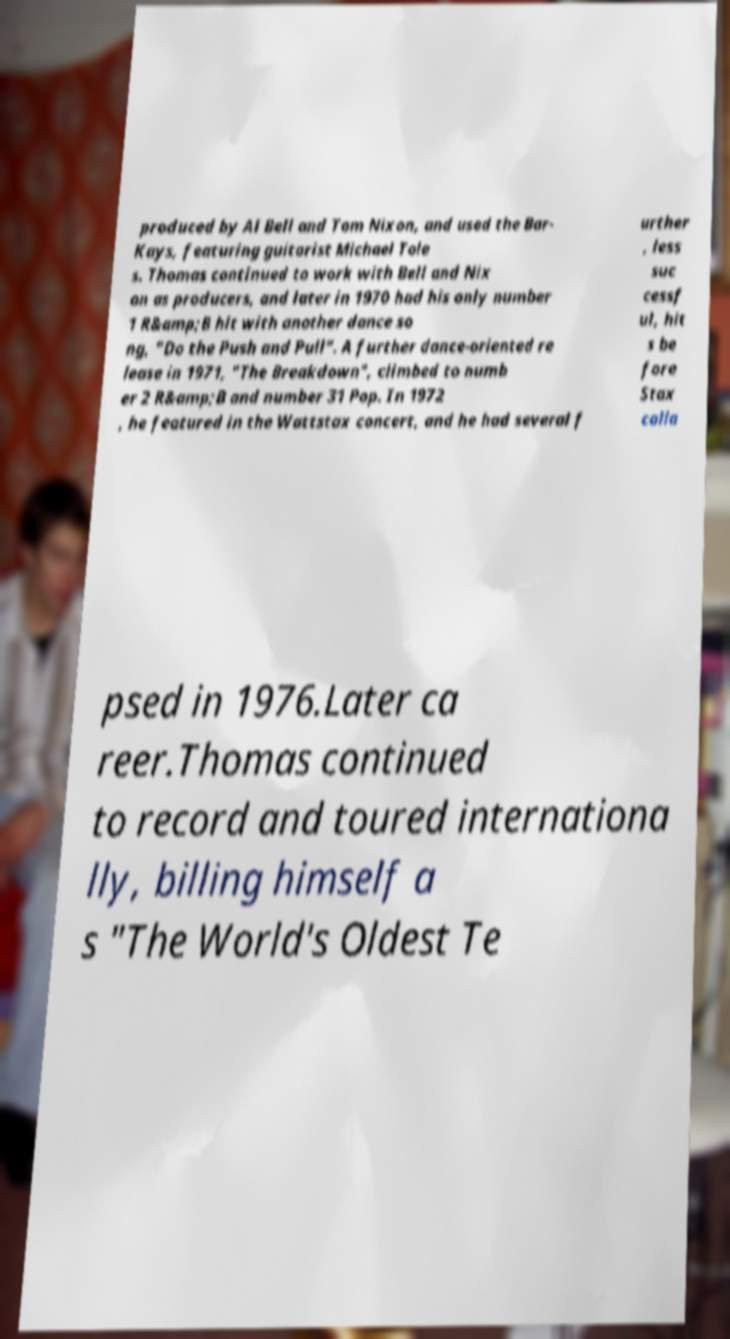For documentation purposes, I need the text within this image transcribed. Could you provide that? produced by Al Bell and Tom Nixon, and used the Bar- Kays, featuring guitarist Michael Tole s. Thomas continued to work with Bell and Nix on as producers, and later in 1970 had his only number 1 R&amp;B hit with another dance so ng, "Do the Push and Pull". A further dance-oriented re lease in 1971, "The Breakdown", climbed to numb er 2 R&amp;B and number 31 Pop. In 1972 , he featured in the Wattstax concert, and he had several f urther , less suc cessf ul, hit s be fore Stax colla psed in 1976.Later ca reer.Thomas continued to record and toured internationa lly, billing himself a s "The World's Oldest Te 